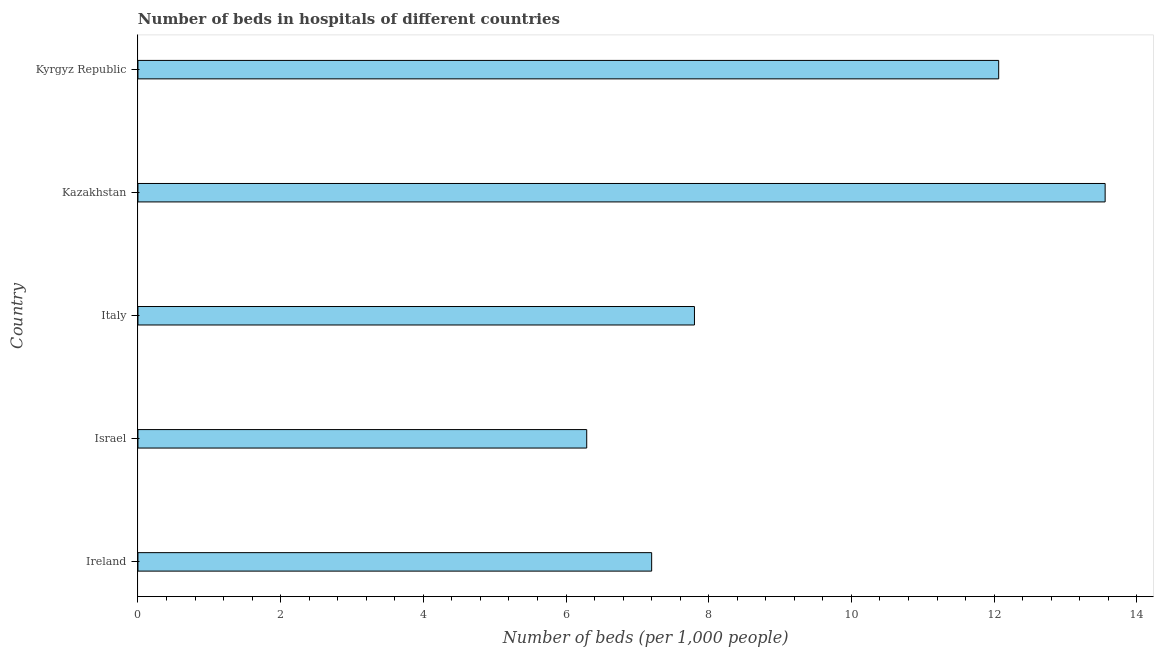Does the graph contain any zero values?
Ensure brevity in your answer.  No. Does the graph contain grids?
Offer a terse response. No. What is the title of the graph?
Ensure brevity in your answer.  Number of beds in hospitals of different countries. What is the label or title of the X-axis?
Offer a very short reply. Number of beds (per 1,0 people). What is the number of hospital beds in Kazakhstan?
Your answer should be very brief. 13.56. Across all countries, what is the maximum number of hospital beds?
Give a very brief answer. 13.56. Across all countries, what is the minimum number of hospital beds?
Provide a short and direct response. 6.29. In which country was the number of hospital beds maximum?
Offer a very short reply. Kazakhstan. In which country was the number of hospital beds minimum?
Ensure brevity in your answer.  Israel. What is the sum of the number of hospital beds?
Ensure brevity in your answer.  46.91. What is the difference between the number of hospital beds in Ireland and Israel?
Keep it short and to the point. 0.91. What is the average number of hospital beds per country?
Provide a succinct answer. 9.38. What is the median number of hospital beds?
Make the answer very short. 7.8. What is the ratio of the number of hospital beds in Italy to that in Kazakhstan?
Offer a very short reply. 0.57. Is the number of hospital beds in Kazakhstan less than that in Kyrgyz Republic?
Keep it short and to the point. No. What is the difference between the highest and the second highest number of hospital beds?
Offer a terse response. 1.49. Is the sum of the number of hospital beds in Ireland and Israel greater than the maximum number of hospital beds across all countries?
Your answer should be compact. No. What is the difference between the highest and the lowest number of hospital beds?
Ensure brevity in your answer.  7.27. In how many countries, is the number of hospital beds greater than the average number of hospital beds taken over all countries?
Make the answer very short. 2. How many bars are there?
Keep it short and to the point. 5. How many countries are there in the graph?
Keep it short and to the point. 5. Are the values on the major ticks of X-axis written in scientific E-notation?
Keep it short and to the point. No. What is the Number of beds (per 1,000 people) of Ireland?
Your answer should be very brief. 7.2. What is the Number of beds (per 1,000 people) of Israel?
Your response must be concise. 6.29. What is the Number of beds (per 1,000 people) in Italy?
Give a very brief answer. 7.8. What is the Number of beds (per 1,000 people) in Kazakhstan?
Provide a short and direct response. 13.56. What is the Number of beds (per 1,000 people) of Kyrgyz Republic?
Offer a terse response. 12.06. What is the difference between the Number of beds (per 1,000 people) in Ireland and Israel?
Offer a terse response. 0.91. What is the difference between the Number of beds (per 1,000 people) in Ireland and Italy?
Make the answer very short. -0.6. What is the difference between the Number of beds (per 1,000 people) in Ireland and Kazakhstan?
Offer a very short reply. -6.36. What is the difference between the Number of beds (per 1,000 people) in Ireland and Kyrgyz Republic?
Make the answer very short. -4.86. What is the difference between the Number of beds (per 1,000 people) in Israel and Italy?
Offer a very short reply. -1.51. What is the difference between the Number of beds (per 1,000 people) in Israel and Kazakhstan?
Ensure brevity in your answer.  -7.27. What is the difference between the Number of beds (per 1,000 people) in Israel and Kyrgyz Republic?
Offer a very short reply. -5.77. What is the difference between the Number of beds (per 1,000 people) in Italy and Kazakhstan?
Your answer should be compact. -5.76. What is the difference between the Number of beds (per 1,000 people) in Italy and Kyrgyz Republic?
Ensure brevity in your answer.  -4.26. What is the difference between the Number of beds (per 1,000 people) in Kazakhstan and Kyrgyz Republic?
Your answer should be compact. 1.49. What is the ratio of the Number of beds (per 1,000 people) in Ireland to that in Israel?
Ensure brevity in your answer.  1.15. What is the ratio of the Number of beds (per 1,000 people) in Ireland to that in Italy?
Provide a short and direct response. 0.92. What is the ratio of the Number of beds (per 1,000 people) in Ireland to that in Kazakhstan?
Keep it short and to the point. 0.53. What is the ratio of the Number of beds (per 1,000 people) in Ireland to that in Kyrgyz Republic?
Your answer should be very brief. 0.6. What is the ratio of the Number of beds (per 1,000 people) in Israel to that in Italy?
Keep it short and to the point. 0.81. What is the ratio of the Number of beds (per 1,000 people) in Israel to that in Kazakhstan?
Your answer should be compact. 0.46. What is the ratio of the Number of beds (per 1,000 people) in Israel to that in Kyrgyz Republic?
Keep it short and to the point. 0.52. What is the ratio of the Number of beds (per 1,000 people) in Italy to that in Kazakhstan?
Your response must be concise. 0.57. What is the ratio of the Number of beds (per 1,000 people) in Italy to that in Kyrgyz Republic?
Provide a short and direct response. 0.65. What is the ratio of the Number of beds (per 1,000 people) in Kazakhstan to that in Kyrgyz Republic?
Your answer should be compact. 1.12. 